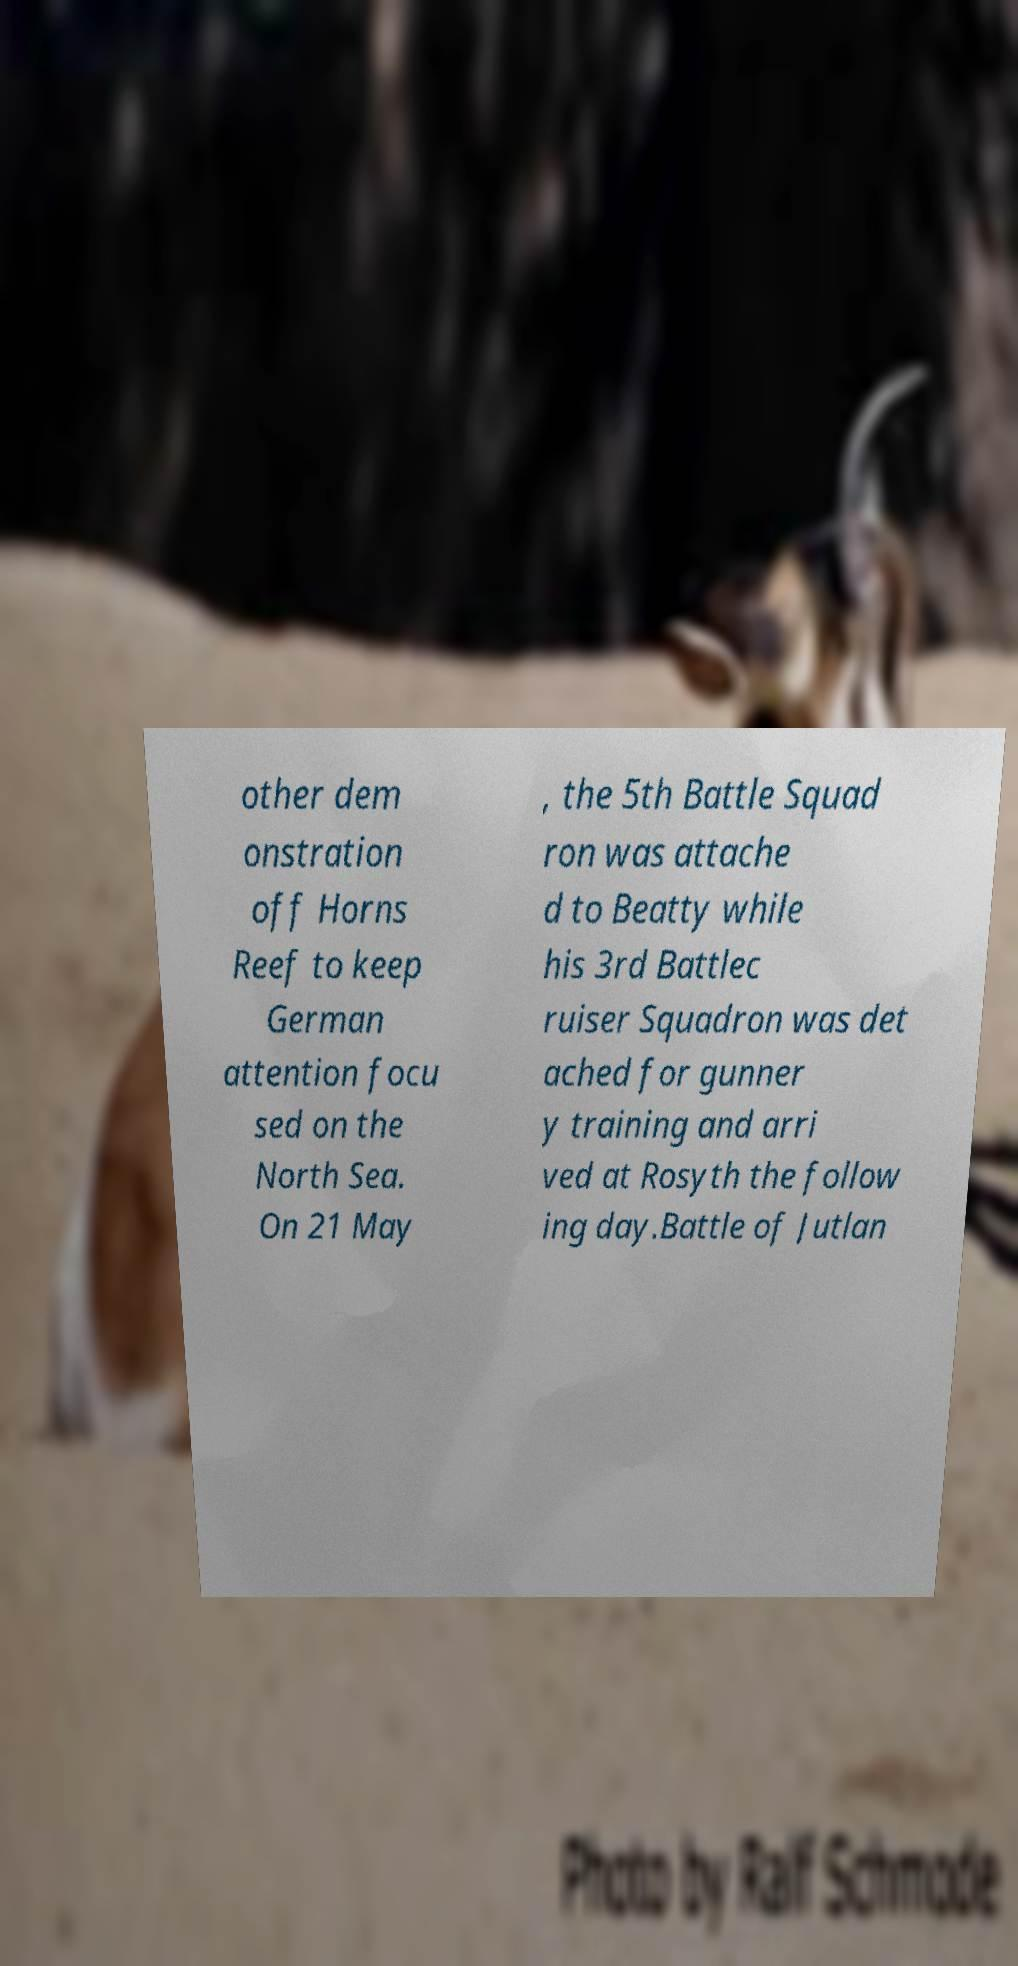Can you accurately transcribe the text from the provided image for me? other dem onstration off Horns Reef to keep German attention focu sed on the North Sea. On 21 May , the 5th Battle Squad ron was attache d to Beatty while his 3rd Battlec ruiser Squadron was det ached for gunner y training and arri ved at Rosyth the follow ing day.Battle of Jutlan 